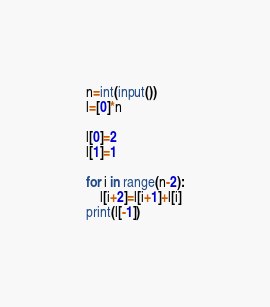<code> <loc_0><loc_0><loc_500><loc_500><_Python_>n=int(input())
l=[0]*n

l[0]=2
l[1]=1

for i in range(n-2):
    l[i+2]=l[i+1]+l[i]
print(l[-1])</code> 